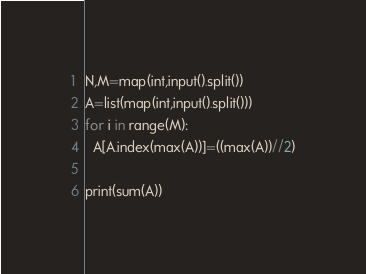Convert code to text. <code><loc_0><loc_0><loc_500><loc_500><_Python_>N,M=map(int,input().split())
A=list(map(int,input().split()))
for i in range(M):
  A[A.index(max(A))]=((max(A))//2)
 
print(sum(A))</code> 